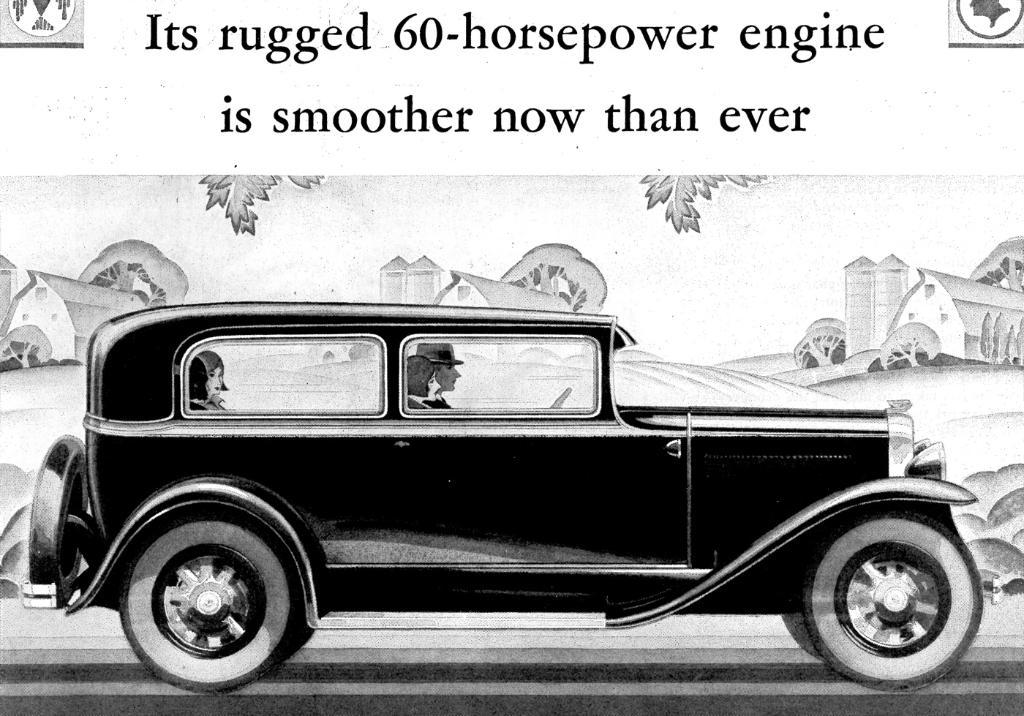What type of artwork is shown in the image? The image is a painting. What is being depicted in the painting? The painting depicts houses and trees. Are there any vehicles in the painting? Yes, there are people sitting in a black color car in the painting. What can be seen at the top of the painting? The sky is visible at the top of the painting. What channel is the painting displayed on? The painting is not displayed on a channel, as it is a static image and not a video or broadcast. 